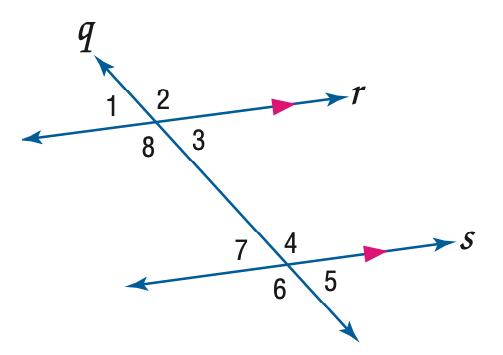Answer the mathemtical geometry problem and directly provide the correct option letter.
Question: Use the figure to find the indicated variable. If m \angle 4 = 2 x - 17 and m \angle 1 = 85, find x.
Choices: A: 51 B: 56 C: 61 D: 85 B 